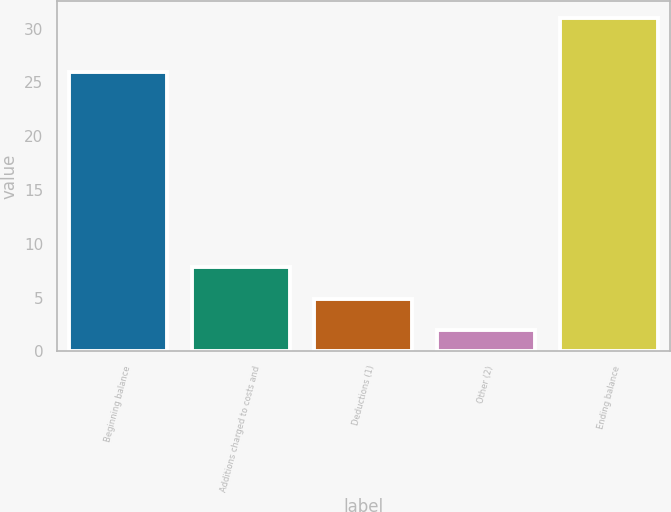Convert chart. <chart><loc_0><loc_0><loc_500><loc_500><bar_chart><fcel>Beginning balance<fcel>Additions charged to costs and<fcel>Deductions (1)<fcel>Other (2)<fcel>Ending balance<nl><fcel>26<fcel>7.8<fcel>4.9<fcel>2<fcel>31<nl></chart> 